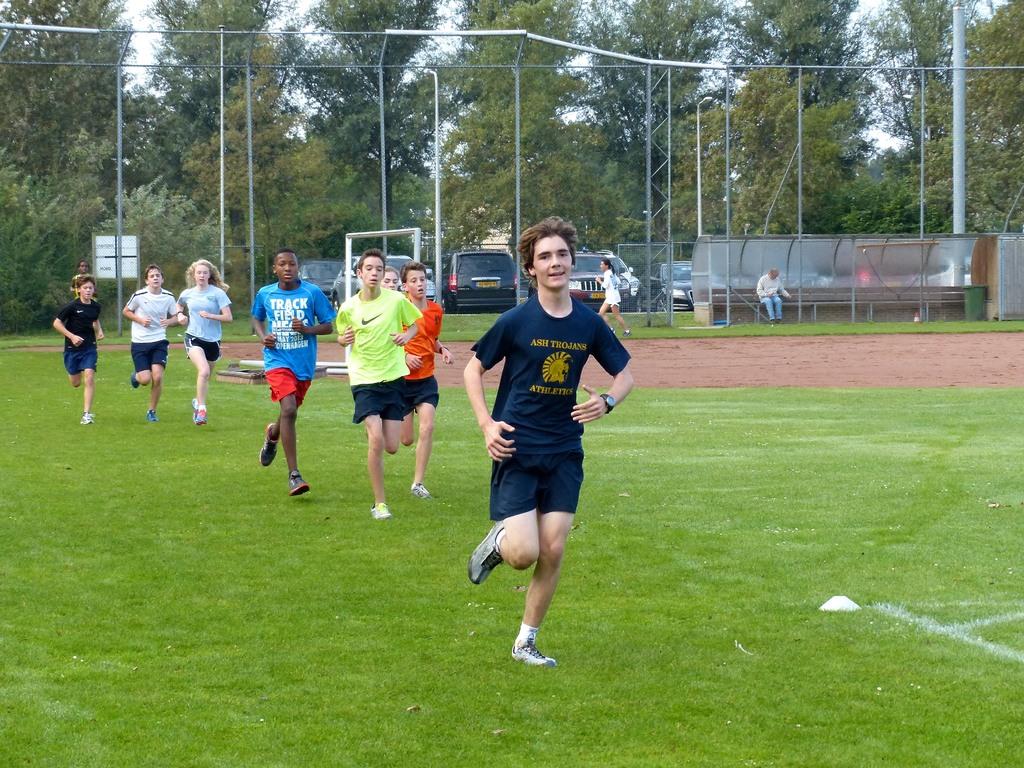What is the top word on the light blue shirt?
Your answer should be compact. Track. Is the first kid running for the trojans?
Your response must be concise. Yes. 